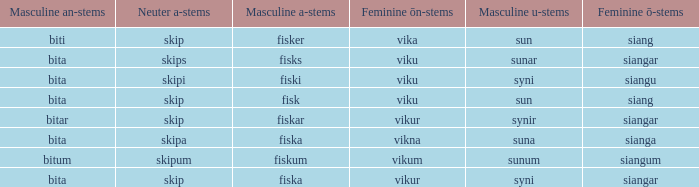What ending does siangu get for ön? Viku. 